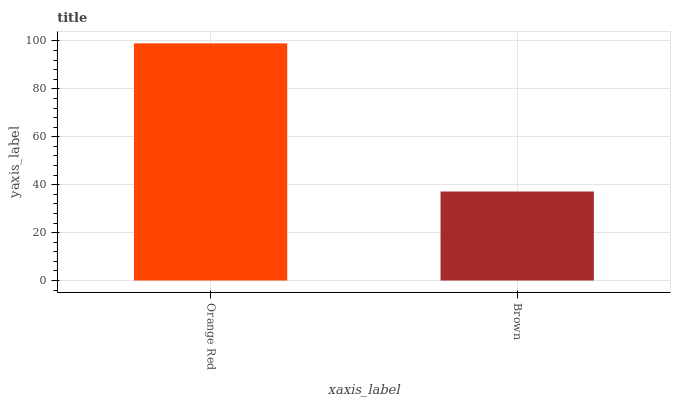Is Brown the minimum?
Answer yes or no. Yes. Is Orange Red the maximum?
Answer yes or no. Yes. Is Brown the maximum?
Answer yes or no. No. Is Orange Red greater than Brown?
Answer yes or no. Yes. Is Brown less than Orange Red?
Answer yes or no. Yes. Is Brown greater than Orange Red?
Answer yes or no. No. Is Orange Red less than Brown?
Answer yes or no. No. Is Orange Red the high median?
Answer yes or no. Yes. Is Brown the low median?
Answer yes or no. Yes. Is Brown the high median?
Answer yes or no. No. Is Orange Red the low median?
Answer yes or no. No. 